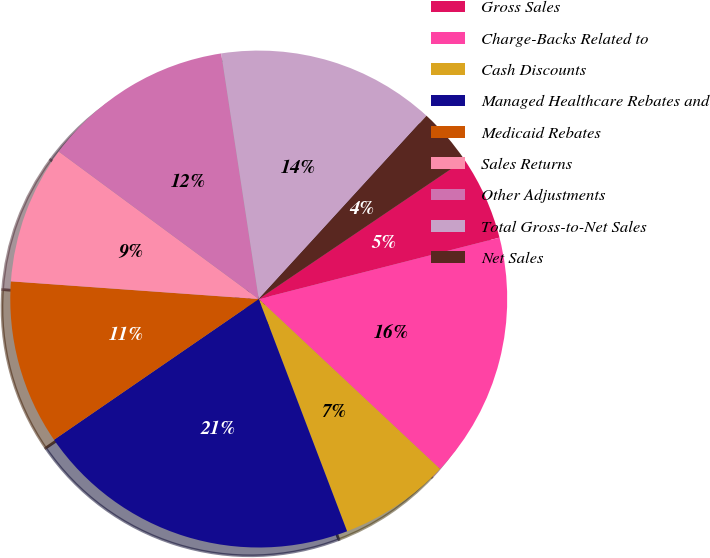<chart> <loc_0><loc_0><loc_500><loc_500><pie_chart><fcel>Gross Sales<fcel>Charge-Backs Related to<fcel>Cash Discounts<fcel>Managed Healthcare Rebates and<fcel>Medicaid Rebates<fcel>Sales Returns<fcel>Other Adjustments<fcel>Total Gross-to-Net Sales<fcel>Net Sales<nl><fcel>5.49%<fcel>15.96%<fcel>7.23%<fcel>21.2%<fcel>10.72%<fcel>8.98%<fcel>12.47%<fcel>14.21%<fcel>3.74%<nl></chart> 